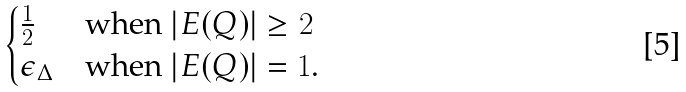<formula> <loc_0><loc_0><loc_500><loc_500>\begin{cases} \frac { 1 } { 2 } & \text {when $|E(Q)|\geq 2$} \\ \epsilon _ { \Delta } & \text {when $|E(Q)|=1$.} \end{cases}</formula> 